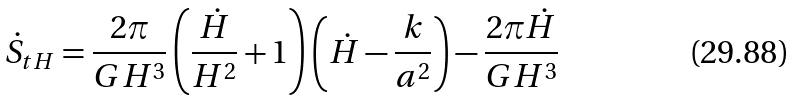<formula> <loc_0><loc_0><loc_500><loc_500>\dot { S } _ { t H } = \frac { 2 \pi } { G H ^ { 3 } } \left ( \frac { \dot { H } } { H ^ { 2 } } + 1 \right ) \left ( \dot { H } - \frac { k } { a ^ { 2 } } \right ) - \frac { 2 \pi \dot { H } } { G H ^ { 3 } }</formula> 